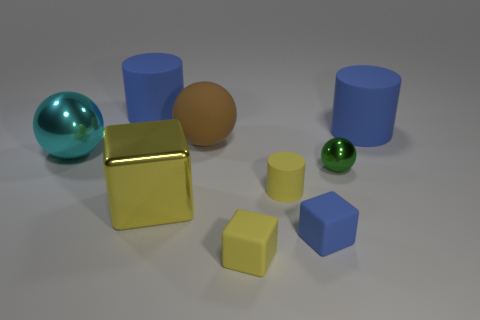Subtract all blue rubber cylinders. How many cylinders are left? 1 Add 1 tiny red rubber cylinders. How many objects exist? 10 Subtract all yellow cylinders. How many cylinders are left? 2 Subtract all red blocks. How many yellow cylinders are left? 1 Subtract 2 yellow blocks. How many objects are left? 7 Subtract all blocks. How many objects are left? 6 Subtract 1 spheres. How many spheres are left? 2 Subtract all purple blocks. Subtract all brown cylinders. How many blocks are left? 3 Subtract all large yellow rubber objects. Subtract all green things. How many objects are left? 8 Add 6 large metallic balls. How many large metallic balls are left? 7 